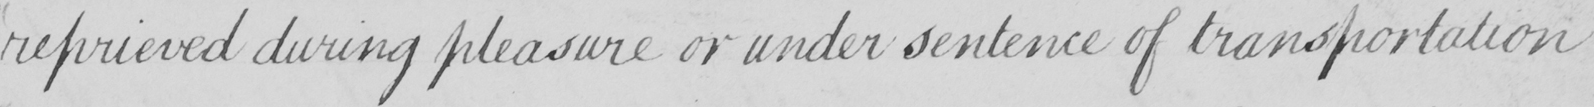Please provide the text content of this handwritten line. reprieved during pleasure or under sentence of transportation 